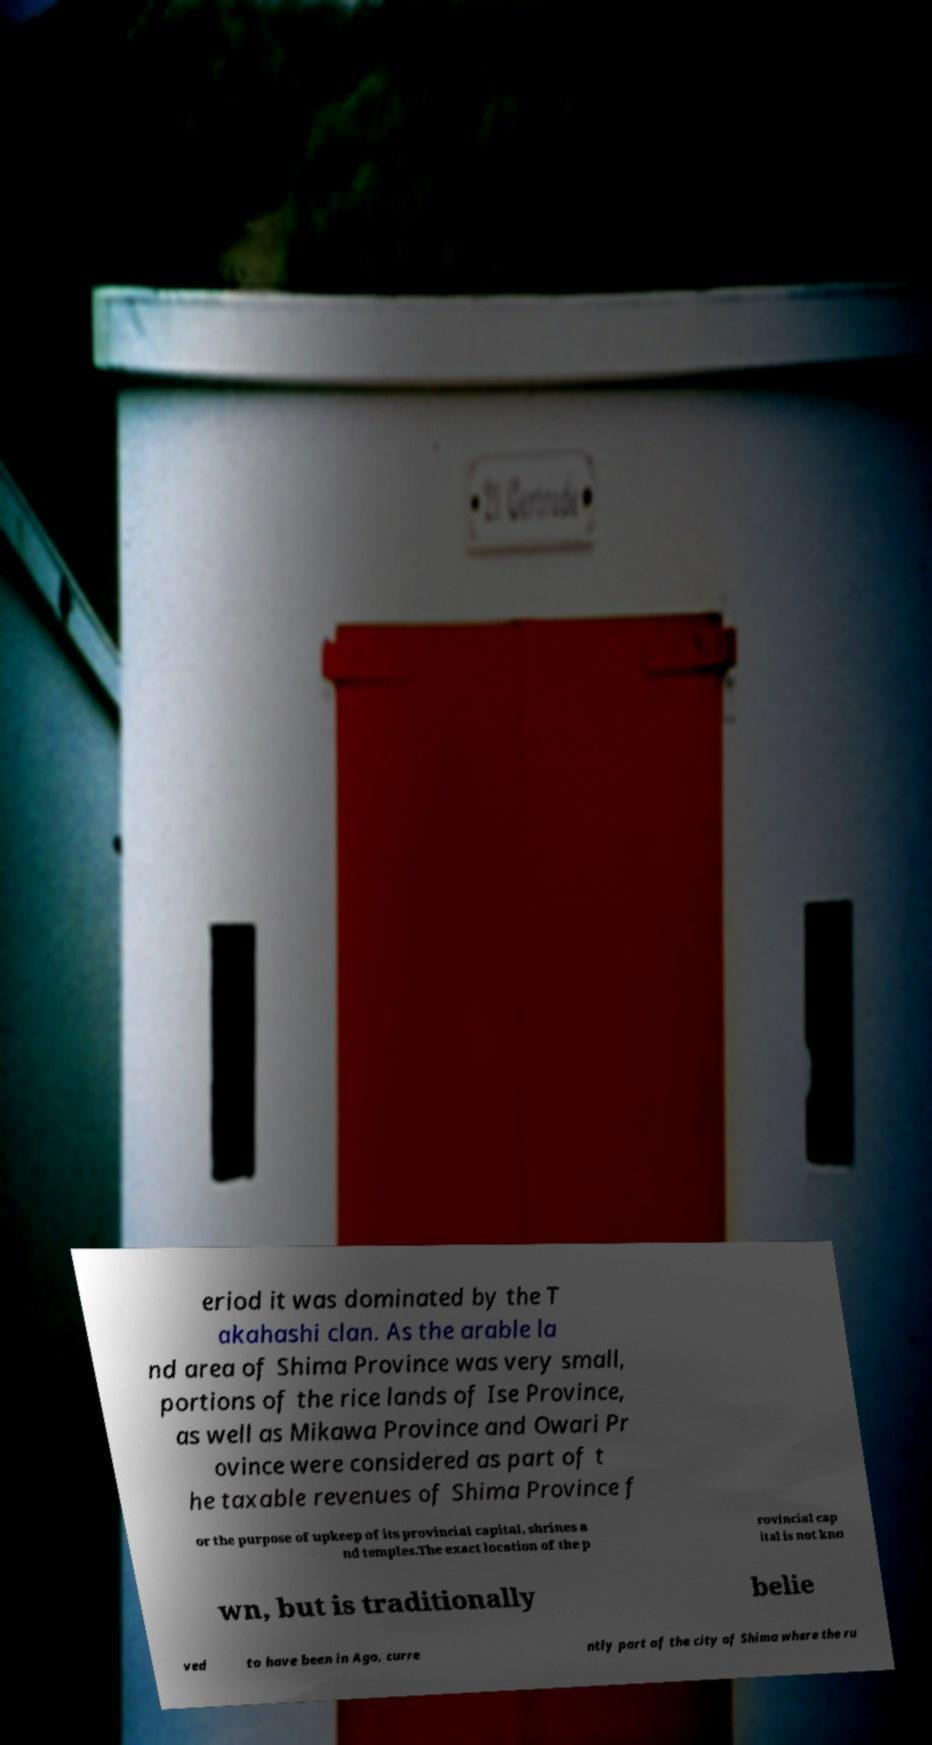Can you read and provide the text displayed in the image?This photo seems to have some interesting text. Can you extract and type it out for me? eriod it was dominated by the T akahashi clan. As the arable la nd area of Shima Province was very small, portions of the rice lands of Ise Province, as well as Mikawa Province and Owari Pr ovince were considered as part of t he taxable revenues of Shima Province f or the purpose of upkeep of its provincial capital, shrines a nd temples.The exact location of the p rovincial cap ital is not kno wn, but is traditionally belie ved to have been in Ago, curre ntly part of the city of Shima where the ru 